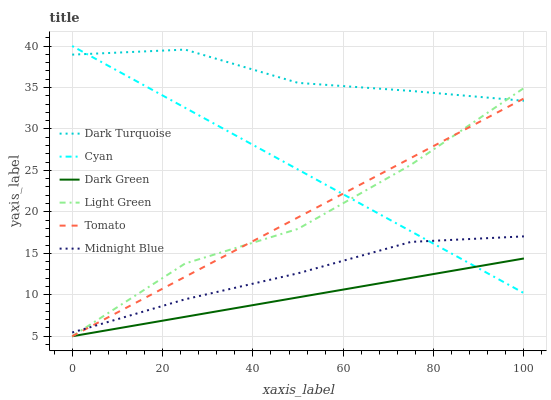Does Dark Green have the minimum area under the curve?
Answer yes or no. Yes. Does Dark Turquoise have the maximum area under the curve?
Answer yes or no. Yes. Does Midnight Blue have the minimum area under the curve?
Answer yes or no. No. Does Midnight Blue have the maximum area under the curve?
Answer yes or no. No. Is Dark Green the smoothest?
Answer yes or no. Yes. Is Light Green the roughest?
Answer yes or no. Yes. Is Midnight Blue the smoothest?
Answer yes or no. No. Is Midnight Blue the roughest?
Answer yes or no. No. Does Tomato have the lowest value?
Answer yes or no. Yes. Does Midnight Blue have the lowest value?
Answer yes or no. No. Does Cyan have the highest value?
Answer yes or no. Yes. Does Midnight Blue have the highest value?
Answer yes or no. No. Is Dark Green less than Midnight Blue?
Answer yes or no. Yes. Is Dark Turquoise greater than Dark Green?
Answer yes or no. Yes. Does Cyan intersect Dark Green?
Answer yes or no. Yes. Is Cyan less than Dark Green?
Answer yes or no. No. Is Cyan greater than Dark Green?
Answer yes or no. No. Does Dark Green intersect Midnight Blue?
Answer yes or no. No. 